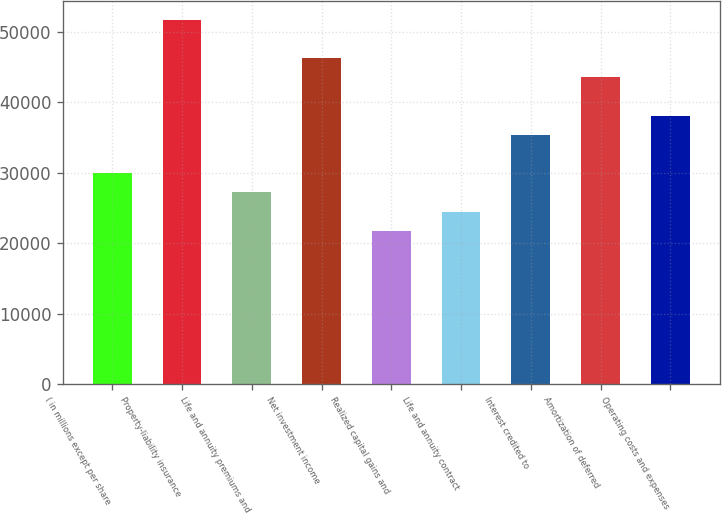Convert chart to OTSL. <chart><loc_0><loc_0><loc_500><loc_500><bar_chart><fcel>( in millions except per share<fcel>Property-liability insurance<fcel>Life and annuity premiums and<fcel>Net investment income<fcel>Realized capital gains and<fcel>Life and annuity contract<fcel>Interest credited to<fcel>Amortization of deferred<fcel>Operating costs and expenses<nl><fcel>29956.2<fcel>51741.4<fcel>27233<fcel>46295.1<fcel>21786.7<fcel>24509.9<fcel>35402.5<fcel>43571.9<fcel>38125.6<nl></chart> 